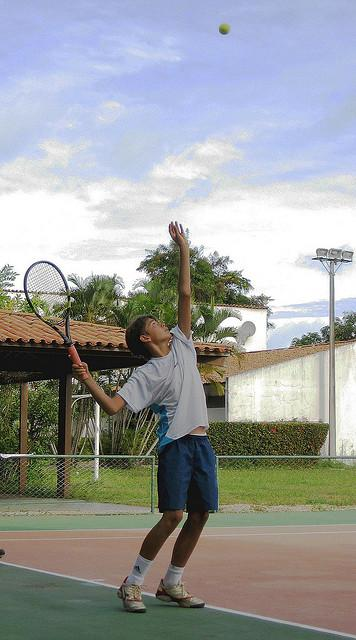Why is he standing like that?

Choices:
A) ball coming
B) is fighting
C) is afraid
D) is falling ball coming 